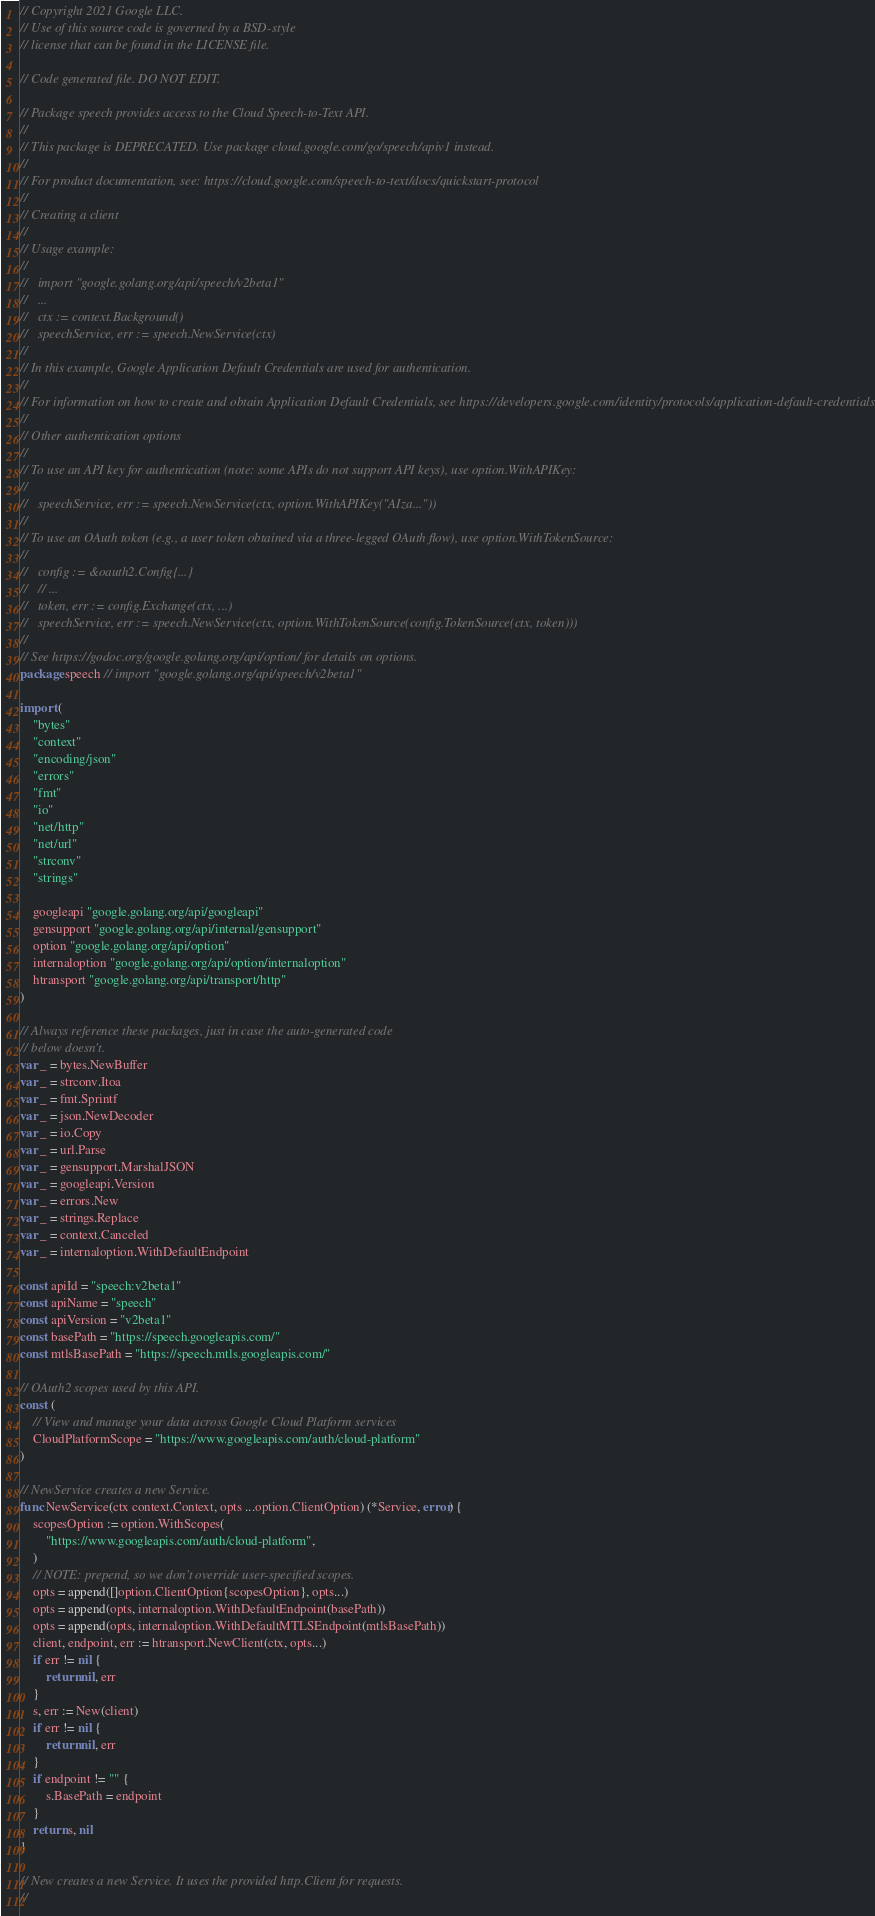<code> <loc_0><loc_0><loc_500><loc_500><_Go_>// Copyright 2021 Google LLC.
// Use of this source code is governed by a BSD-style
// license that can be found in the LICENSE file.

// Code generated file. DO NOT EDIT.

// Package speech provides access to the Cloud Speech-to-Text API.
//
// This package is DEPRECATED. Use package cloud.google.com/go/speech/apiv1 instead.
//
// For product documentation, see: https://cloud.google.com/speech-to-text/docs/quickstart-protocol
//
// Creating a client
//
// Usage example:
//
//   import "google.golang.org/api/speech/v2beta1"
//   ...
//   ctx := context.Background()
//   speechService, err := speech.NewService(ctx)
//
// In this example, Google Application Default Credentials are used for authentication.
//
// For information on how to create and obtain Application Default Credentials, see https://developers.google.com/identity/protocols/application-default-credentials.
//
// Other authentication options
//
// To use an API key for authentication (note: some APIs do not support API keys), use option.WithAPIKey:
//
//   speechService, err := speech.NewService(ctx, option.WithAPIKey("AIza..."))
//
// To use an OAuth token (e.g., a user token obtained via a three-legged OAuth flow), use option.WithTokenSource:
//
//   config := &oauth2.Config{...}
//   // ...
//   token, err := config.Exchange(ctx, ...)
//   speechService, err := speech.NewService(ctx, option.WithTokenSource(config.TokenSource(ctx, token)))
//
// See https://godoc.org/google.golang.org/api/option/ for details on options.
package speech // import "google.golang.org/api/speech/v2beta1"

import (
	"bytes"
	"context"
	"encoding/json"
	"errors"
	"fmt"
	"io"
	"net/http"
	"net/url"
	"strconv"
	"strings"

	googleapi "google.golang.org/api/googleapi"
	gensupport "google.golang.org/api/internal/gensupport"
	option "google.golang.org/api/option"
	internaloption "google.golang.org/api/option/internaloption"
	htransport "google.golang.org/api/transport/http"
)

// Always reference these packages, just in case the auto-generated code
// below doesn't.
var _ = bytes.NewBuffer
var _ = strconv.Itoa
var _ = fmt.Sprintf
var _ = json.NewDecoder
var _ = io.Copy
var _ = url.Parse
var _ = gensupport.MarshalJSON
var _ = googleapi.Version
var _ = errors.New
var _ = strings.Replace
var _ = context.Canceled
var _ = internaloption.WithDefaultEndpoint

const apiId = "speech:v2beta1"
const apiName = "speech"
const apiVersion = "v2beta1"
const basePath = "https://speech.googleapis.com/"
const mtlsBasePath = "https://speech.mtls.googleapis.com/"

// OAuth2 scopes used by this API.
const (
	// View and manage your data across Google Cloud Platform services
	CloudPlatformScope = "https://www.googleapis.com/auth/cloud-platform"
)

// NewService creates a new Service.
func NewService(ctx context.Context, opts ...option.ClientOption) (*Service, error) {
	scopesOption := option.WithScopes(
		"https://www.googleapis.com/auth/cloud-platform",
	)
	// NOTE: prepend, so we don't override user-specified scopes.
	opts = append([]option.ClientOption{scopesOption}, opts...)
	opts = append(opts, internaloption.WithDefaultEndpoint(basePath))
	opts = append(opts, internaloption.WithDefaultMTLSEndpoint(mtlsBasePath))
	client, endpoint, err := htransport.NewClient(ctx, opts...)
	if err != nil {
		return nil, err
	}
	s, err := New(client)
	if err != nil {
		return nil, err
	}
	if endpoint != "" {
		s.BasePath = endpoint
	}
	return s, nil
}

// New creates a new Service. It uses the provided http.Client for requests.
//</code> 